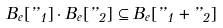Convert formula to latex. <formula><loc_0><loc_0><loc_500><loc_500>B _ { e } [ { \varepsilon _ { 1 } } ] \cdot B _ { e } [ { \varepsilon _ { 2 } } ] \subseteq B _ { e } [ { \varepsilon _ { 1 } + \varepsilon _ { 2 } } ]</formula> 